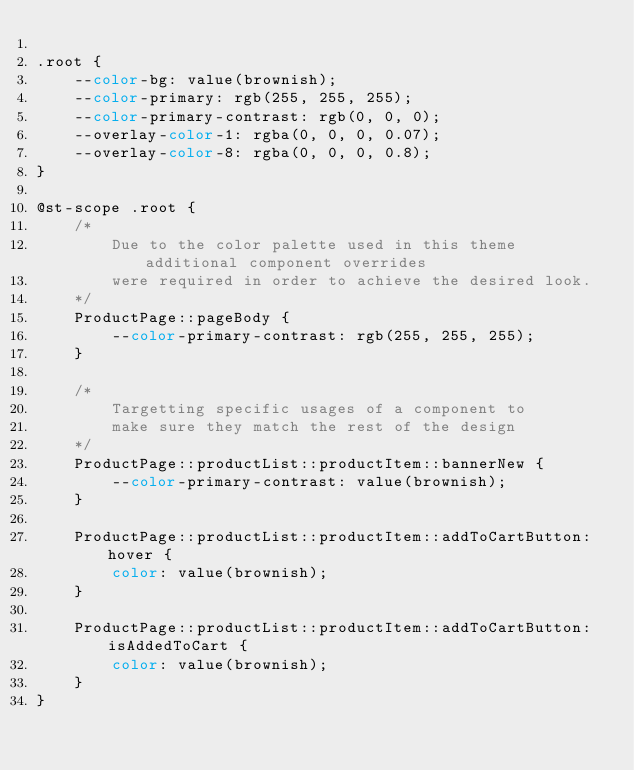<code> <loc_0><loc_0><loc_500><loc_500><_CSS_>
.root {
    --color-bg: value(brownish);
    --color-primary: rgb(255, 255, 255);
    --color-primary-contrast: rgb(0, 0, 0);
    --overlay-color-1: rgba(0, 0, 0, 0.07);
    --overlay-color-8: rgba(0, 0, 0, 0.8);
}

@st-scope .root {
    /* 
        Due to the color palette used in this theme additional component overrides 
        were required in order to achieve the desired look.
    */
    ProductPage::pageBody {
        --color-primary-contrast: rgb(255, 255, 255);
    }

    /* 
        Targetting specific usages of a component to 
        make sure they match the rest of the design
    */
    ProductPage::productList::productItem::bannerNew {
        --color-primary-contrast: value(brownish);
    }

    ProductPage::productList::productItem::addToCartButton:hover {
        color: value(brownish);
    }

    ProductPage::productList::productItem::addToCartButton:isAddedToCart {
        color: value(brownish);
    }
}
</code> 